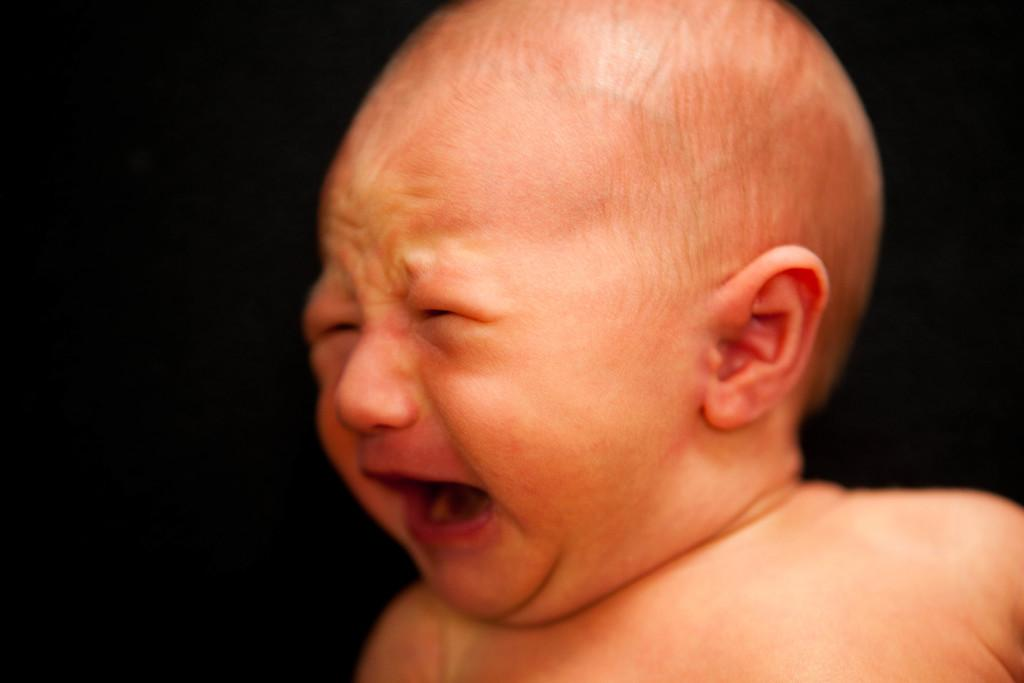What is the main subject of the image? There is a baby in the image. What is the baby doing in the image? The baby is crying. Can you describe the background of the image? The background of the image is dark in color. How many geese are present in the image? There are no geese present in the image; it features a baby who is crying. What type of meat can be seen on the floor in the image? There is no meat present on the floor in the image. 